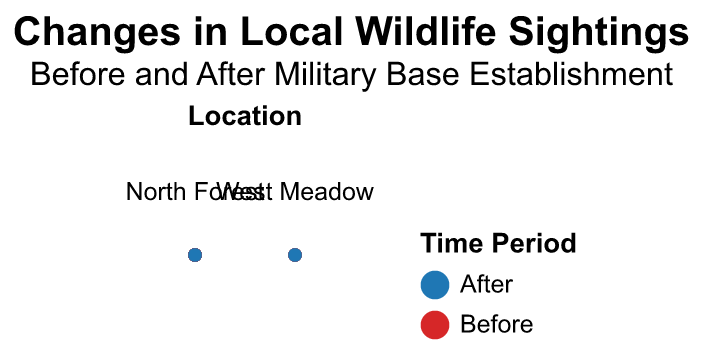how many species are listed in each subplot? The figure is faceted by location into two subplots: North Forest and West Meadow. We need to count the distinct species in each subplot. In the North Forest, the species are Deer, Fox, Eagle, and Rabbit, totaling 4. In the West Meadow, the species are Squirrel and Owl, totaling 2
Answer: North Forest: 4, West Meadow: 2 Which species saw the steepest decline in sightings in the North Forest after the military base establishment? We compare the "Before" and "After" sighting numbers for each species in the North Forest and find the difference. The species are Deer (15), Fox (8), Eagle (6), and Rabbit (25). The Rabbit saw the steepest decline with a difference of 25 sightings
Answer: Rabbit Are there any species whose sighting numbers did not decrease in the West Meadow? We compare the "Before" and "After" numbers for all species in the West Meadow. The species are Squirrel (30 to 10), and Owl (15 to 5), both saw a decrease. Thus, no species maintained their sighting numbers
Answer: No What's the total number of animal sightings in the North Forest before the military base establishment? We sum up the "Before" sighting numbers in the North Forest: 25 (Deer) + 12 (Fox) + 8 (Eagle) + 40 (Rabbit) = 85
Answer: 85 By how much did squirrel sightings decrease in the West Meadow? We calculate the difference in sightings numbers for Squirrel in the West Meadow before and after the military base establishment: 30 (Before) - 10 (After) = 20
Answer: 20 What is the largest radius value in the subplot for the West Meadow After period? Comparing the radius values for the West Meadow After period: Squirrel (10) and Owl (5), the largest value is 10.
Answer: 10 Which location saw the greatest reduction in total wildlife sightings after the military base establishment? We sum the reductions for each location. For the North Forest: Deer (15), Fox (8), Eagle (6), Rabbit (25) = 54. For the West Meadow: Squirrel (20), Owl (10) = 30. The North Forest saw the greatest reduction with a total of 54 sightings.
Answer: North Forest How does the color coding differentiate between the time periods, and what are the colors used? The figure uses color coding to differentiate "Before" and "After" periods. The "Before" sightings are colored blue, while the "After" sightings are colored red.
Answer: Blue for Before, Red for After Which species had the least number of sightings before the military base establishment, and in which location? By examining the "Before" sightings, the least number is 8 (Eagle) in the North Forest.
Answer: Eagle, North Forest 